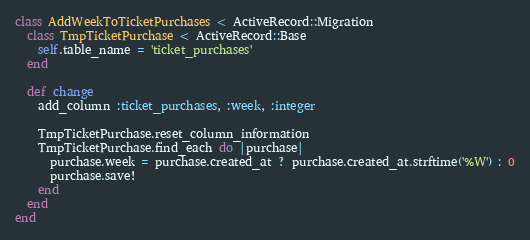Convert code to text. <code><loc_0><loc_0><loc_500><loc_500><_Ruby_>class AddWeekToTicketPurchases < ActiveRecord::Migration
  class TmpTicketPurchase < ActiveRecord::Base
    self.table_name = 'ticket_purchases'
  end

  def change
    add_column :ticket_purchases, :week, :integer

    TmpTicketPurchase.reset_column_information
    TmpTicketPurchase.find_each do |purchase|
      purchase.week = purchase.created_at ? purchase.created_at.strftime('%W') : 0
      purchase.save!
    end
  end
end
</code> 